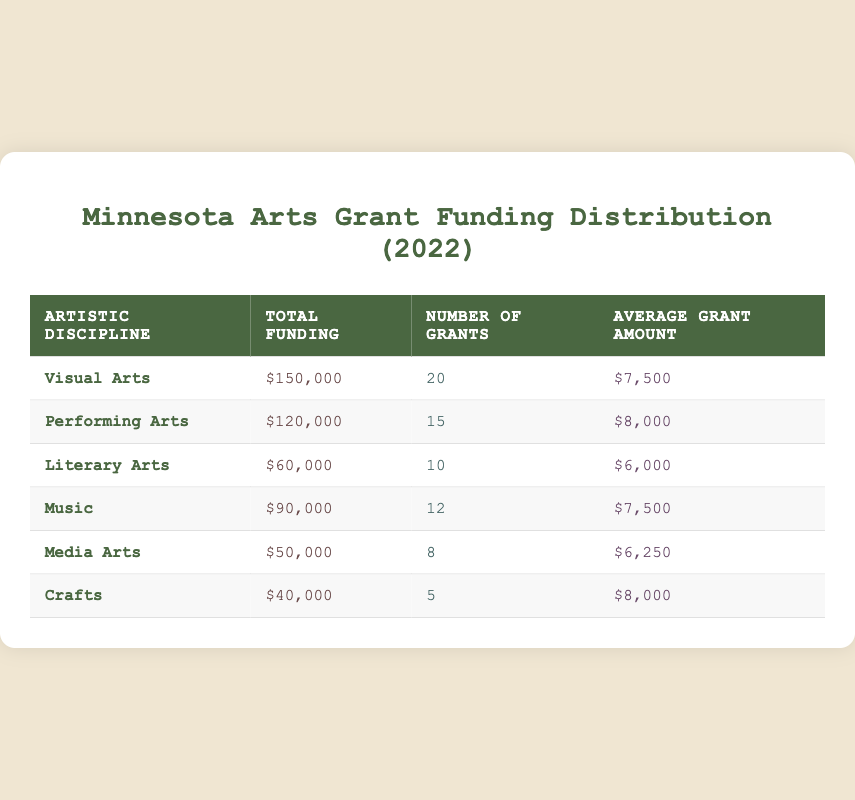What is the total funding for Visual Arts? The table shows that the total funding allocated to Visual Arts is listed directly under the "Total Funding" column next to the "Visual Arts" row. The value is $150,000.
Answer: $150,000 How many grants were awarded for Performing Arts? The "Number of Grants" column has a value corresponding to Performing Arts. According to the table, 15 grants were awarded for Performing Arts.
Answer: 15 What was the average grant amount for Crafts? The average grant amount is found in the "Average Grant Amount" column for the Crafts row, which is $8,000.
Answer: $8,000 Which artistic discipline received the least total funding? To find the artistic discipline with the least total funding, you can compare the "Total Funding" values across all rows. Crafts has the lowest value at $40,000.
Answer: Crafts If you combine the total funding for Music and Media Arts, what will the total be? First, look at the total funding for Music, which is $90,000, and for Media Arts, which is $50,000. Add these two amounts together: $90,000 + $50,000 = $140,000.
Answer: $140,000 Did the Literary Arts receive more total funding than Media Arts? By comparing the values, Literary Arts has a total funding of $60,000, which is greater than Media Arts' total of $50,000. Therefore, it is true that Literary Arts received more funding.
Answer: Yes What is the average grant amount across all artistic disciplines? To find the average, calculate the total funding first: $150,000 + $120,000 + $60,000 + $90,000 + $50,000 + $40,000 = $510,000. Next, count the total number of grants: 20 + 15 + 10 + 12 + 8 + 5 = 70. Now, divide the total funding by the number of grants: $510,000 / 70 = $7,285.71.
Answer: $7,285.71 Is the average grant amount for Music equal to the average grant amount for Visual Arts? The average grant amount for Music is $7,500, while for Visual Arts, it is also $7,500. Since both are equal, the statement is true.
Answer: Yes How many more grants were awarded for Visual Arts than for Music? The number of grants for Visual Arts is 20, while for Music, it is 12. To find the difference, subtract the number for Music from Visual Arts: 20 - 12 = 8.
Answer: 8 